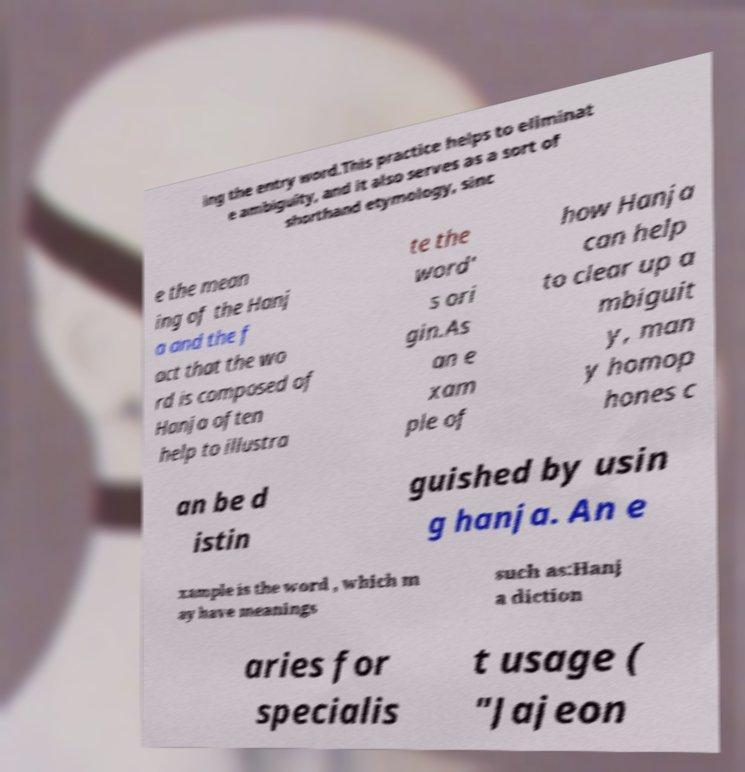Please read and relay the text visible in this image. What does it say? ing the entry word.This practice helps to eliminat e ambiguity, and it also serves as a sort of shorthand etymology, sinc e the mean ing of the Hanj a and the f act that the wo rd is composed of Hanja often help to illustra te the word' s ori gin.As an e xam ple of how Hanja can help to clear up a mbiguit y, man y homop hones c an be d istin guished by usin g hanja. An e xample is the word , which m ay have meanings such as:Hanj a diction aries for specialis t usage ( "Jajeon 